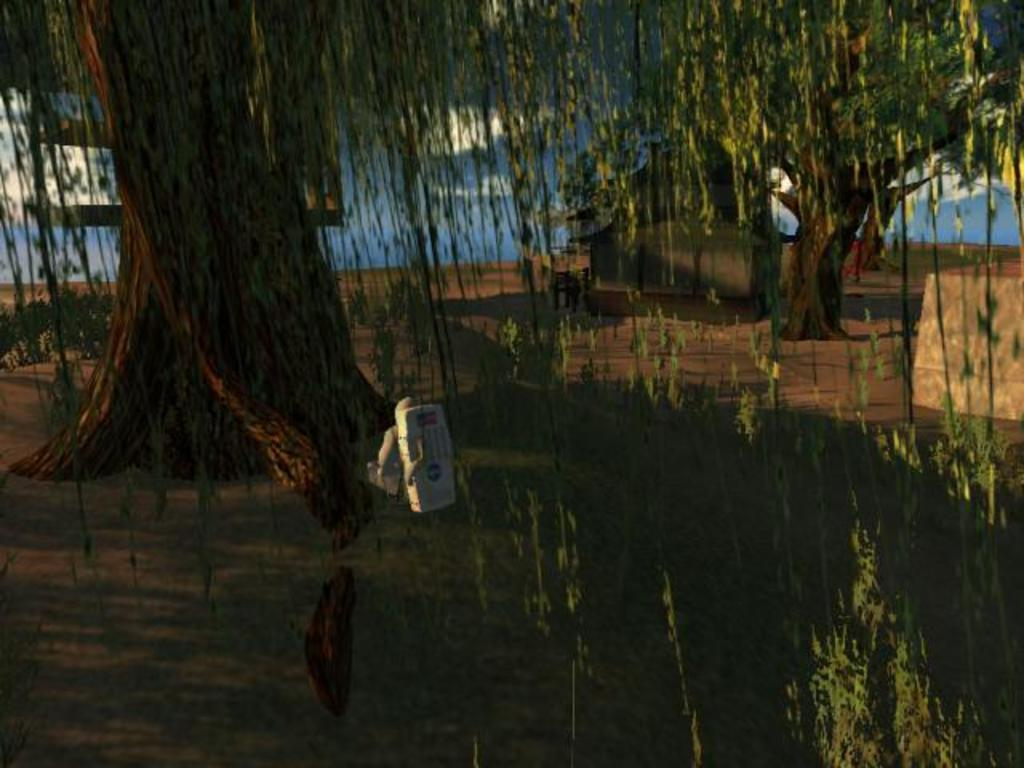What is the main object in the image? There is a machine in the image. What can be seen in the background of the image? There are trees in the image. What is the opinion of the crow on the toothbrush in the image? There is no crow or toothbrush present in the image, so it is not possible to determine the opinion of a crow on a toothbrush. 